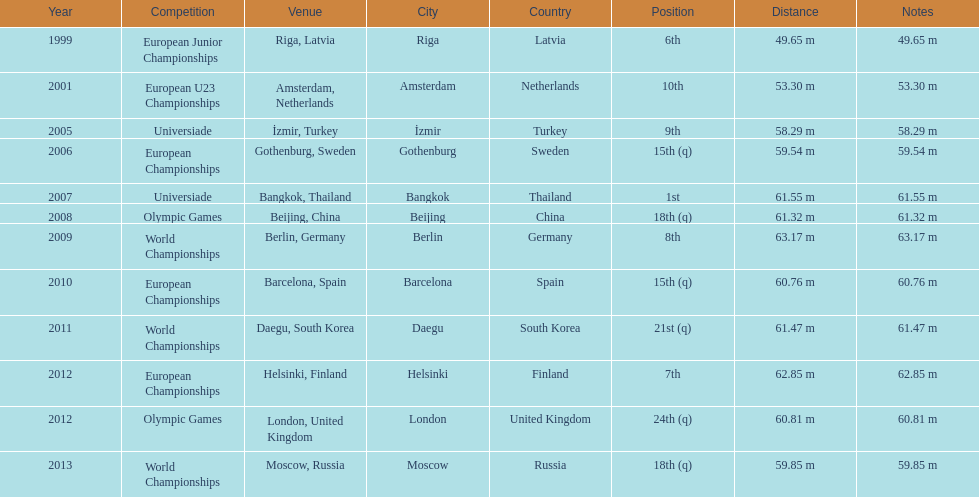Parse the table in full. {'header': ['Year', 'Competition', 'Venue', 'City', 'Country', 'Position', 'Distance', 'Notes'], 'rows': [['1999', 'European Junior Championships', 'Riga, Latvia', 'Riga', 'Latvia', '6th', '49.65 m', '49.65 m'], ['2001', 'European U23 Championships', 'Amsterdam, Netherlands', 'Amsterdam', 'Netherlands', '10th', '53.30 m', '53.30 m'], ['2005', 'Universiade', 'İzmir, Turkey', 'İzmir', 'Turkey', '9th', '58.29 m', '58.29 m'], ['2006', 'European Championships', 'Gothenburg, Sweden', 'Gothenburg', 'Sweden', '15th (q)', '59.54 m', '59.54 m'], ['2007', 'Universiade', 'Bangkok, Thailand', 'Bangkok', 'Thailand', '1st', '61.55 m', '61.55 m'], ['2008', 'Olympic Games', 'Beijing, China', 'Beijing', 'China', '18th (q)', '61.32 m', '61.32 m'], ['2009', 'World Championships', 'Berlin, Germany', 'Berlin', 'Germany', '8th', '63.17 m', '63.17 m'], ['2010', 'European Championships', 'Barcelona, Spain', 'Barcelona', 'Spain', '15th (q)', '60.76 m', '60.76 m'], ['2011', 'World Championships', 'Daegu, South Korea', 'Daegu', 'South Korea', '21st (q)', '61.47 m', '61.47 m'], ['2012', 'European Championships', 'Helsinki, Finland', 'Helsinki', 'Finland', '7th', '62.85 m', '62.85 m'], ['2012', 'Olympic Games', 'London, United Kingdom', 'London', 'United Kingdom', '24th (q)', '60.81 m', '60.81 m'], ['2013', 'World Championships', 'Moscow, Russia', 'Moscow', 'Russia', '18th (q)', '59.85 m', '59.85 m']]} How many world championships has he been in? 3. 